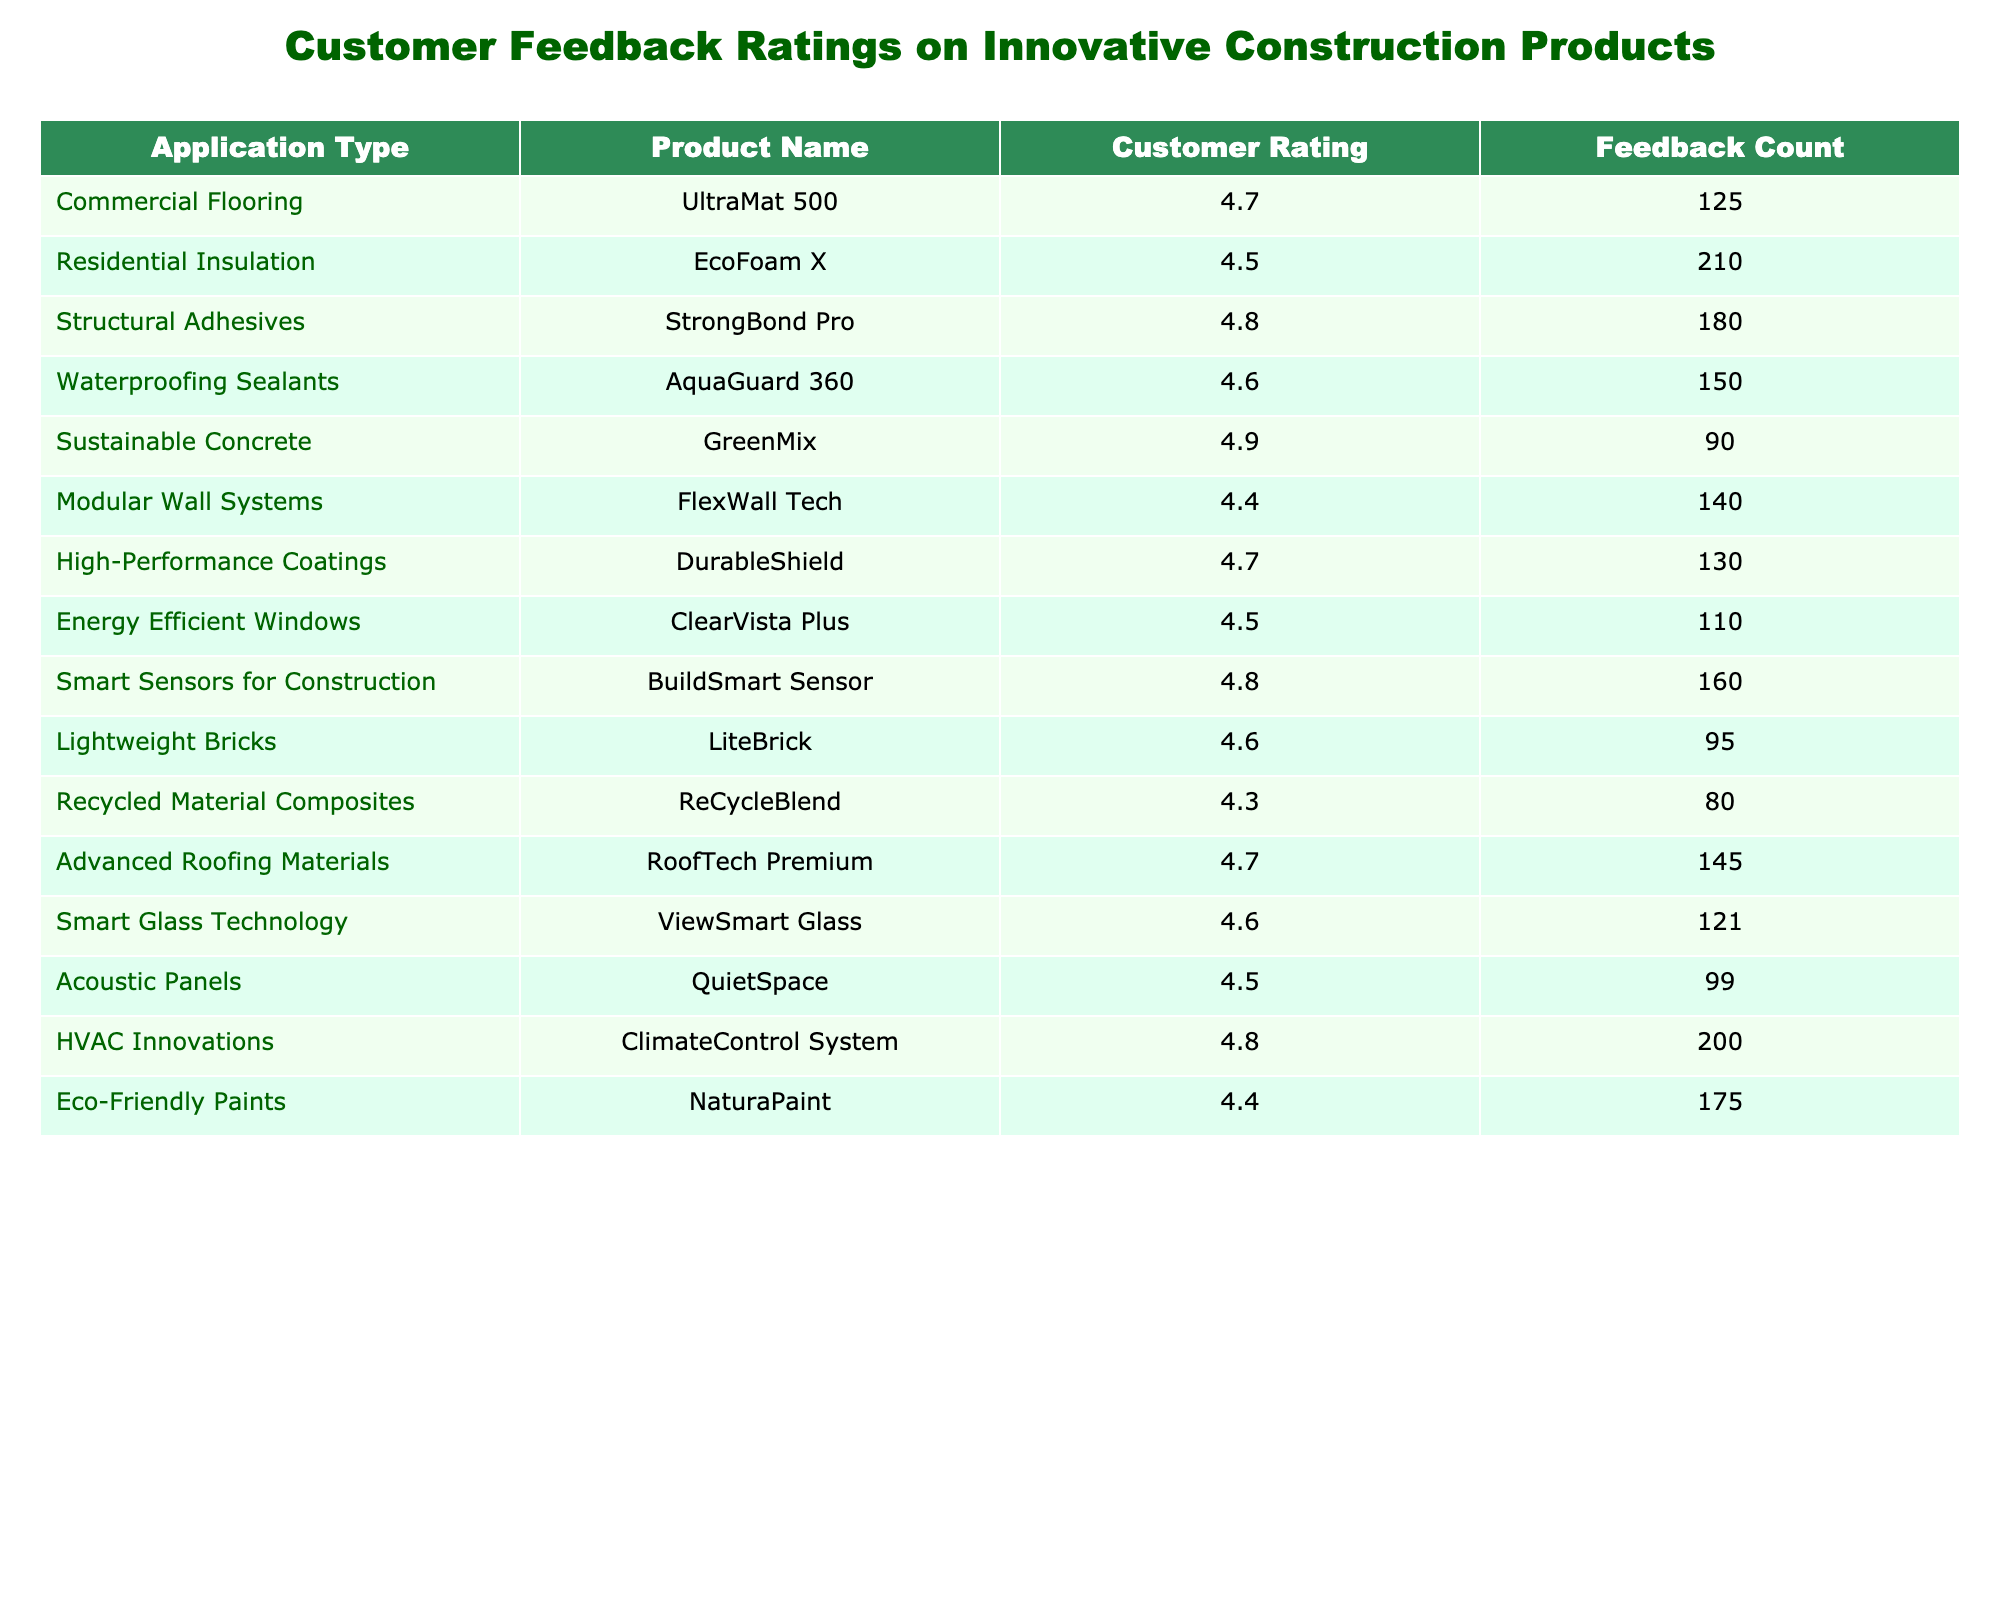What is the customer rating for EcoFoam X? The table lists EcoFoam X under "Residential Insulation" with a customer rating of 4.5.
Answer: 4.5 Which product has received the highest customer rating? The highest customer rating in the table is 4.9, attributed to the "Sustainable Concrete" product called GreenMix.
Answer: GreenMix What is the feedback count for the product StrongBond Pro? Looking at the table, the feedback count for StrongBond Pro under "Structural Adhesives" is 180.
Answer: 180 What is the average customer rating for products in the "Modular Wall Systems" and "Lightweight Bricks" categories? The ratings for FlexWall Tech (4.4) and LiteBrick (4.6) are added, giving a total of 9.0. Dividing by 2, the average is 4.5.
Answer: 4.5 Is there a product in the table that received a customer rating below 4.4? According to the table, the product ReCycleBlend is listed with a rating of 4.3, which is below 4.4.
Answer: Yes What is the sum of feedback counts for all the products related to energy efficiency? The feedback counts for the relevant products are ClimateControl System (200) and ClearVista Plus (110). Their sum is 200 + 110 = 310.
Answer: 310 Which application type received the most feedback, and what is the corresponding count? The application with the most feedback is "Residential Insulation" with a feedback count of 210 for the product EcoFoam X.
Answer: Residential Insulation, 210 How many products received a rating of 4.6 or higher? Counting the ratings that are 4.6 or higher: UltraMat 500 (4.7), StrongBond Pro (4.8), AquaGuard 360 (4.6), GreenMix (4.9), DurableShield (4.7), ClearVista Plus (4.5), BuildSmart Sensor (4.8), LiteBrick (4.6), RoofTech Premium (4.7), ViewSmart Glass (4.6), and HVAC Innovations (4.8) gives a total of 11 products.
Answer: 11 What percentage of the total feedback counts is attributed to products rated 4.5 and above? Counting the total feedback counts for these products (125 + 210 + 180 + 150 + 90 + 140 + 130 + 110 + 160 + 95 + 80 + 145 + 121 + 99 + 200) gives 1,651, and those rated 4.5 or above account for 1,561 counts. Calculating the percentage: (1,561/1,651) * 100 ≈ 94.5%.
Answer: 94.5% What is the difference between the highest and lowest feedback counts among the products? The highest feedback count is 210 for the product EcoFoam X, and the lowest is 80 for the product ReCycleBlend. The difference is 210 - 80 = 130.
Answer: 130 